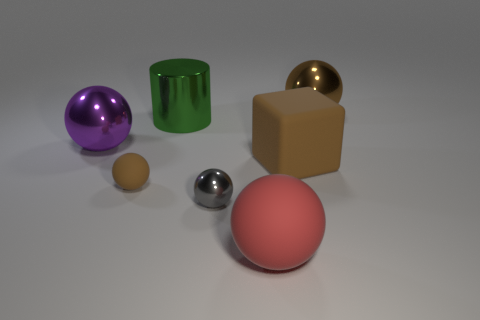Add 1 small gray metal objects. How many objects exist? 8 Subtract all blocks. How many objects are left? 6 Subtract all big shiny cylinders. Subtract all cylinders. How many objects are left? 5 Add 2 purple shiny objects. How many purple shiny objects are left? 3 Add 7 small yellow rubber objects. How many small yellow rubber objects exist? 7 Subtract 0 brown cylinders. How many objects are left? 7 